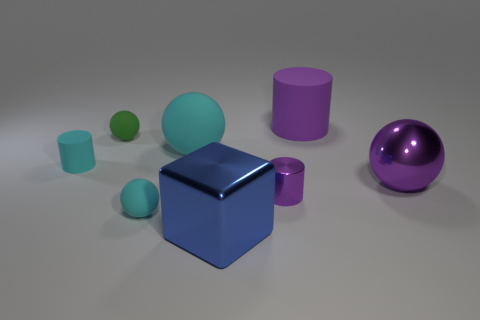Can you describe the shapes and their colors in the image? Certainly! In the image, you can see a blue cube at the center, and there's a large purple sphere on the right. To the left of the cube, there's a smaller teal cylinder and two spheres, one larger and teal, and a smaller one that's lime green. Behind the blue cube, there is also a purple cylinder. 